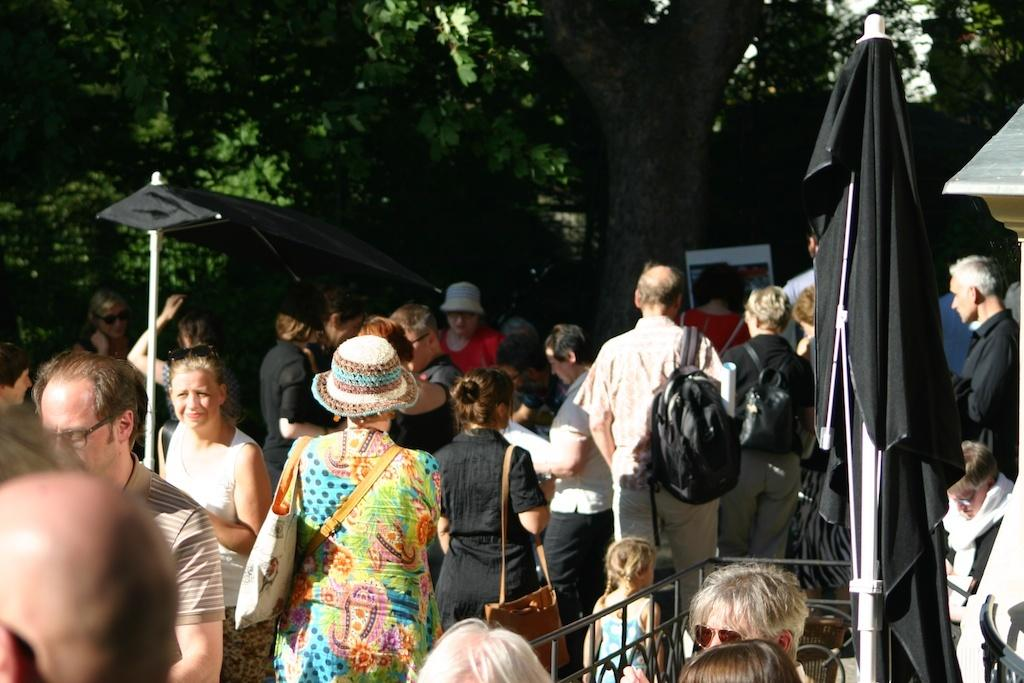What are the persons in the image doing? The persons in the image are standing and walking. What type of temporary shelters can be seen in the image? There are tents in the image. What type of natural vegetation is visible in the image? There are trees in the image. What type of man-made structure is visible in the image? There is a wall in the image. What type of payment method is being used by the persons in the image? There is no indication in the image of any payment method being used. Can you tell me how many friends are visible in the image? The concept of "friends" is not mentioned or depicted in the image. 